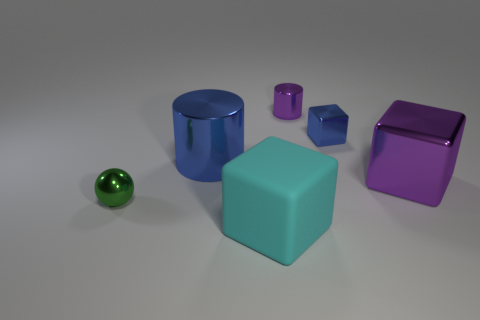What can you infer about the surface the objects are on? The surface appears to be a matte and neutral-toned, likely chosen to emphasize the objects without causing distracting reflections or competing with the colors of the objects for attention. Could this image be of educational value? Absolutely, this image could serve an educational purpose, such as teaching about geometry, colors, size comparison, or photographic composition through the use of 3D rendering. 